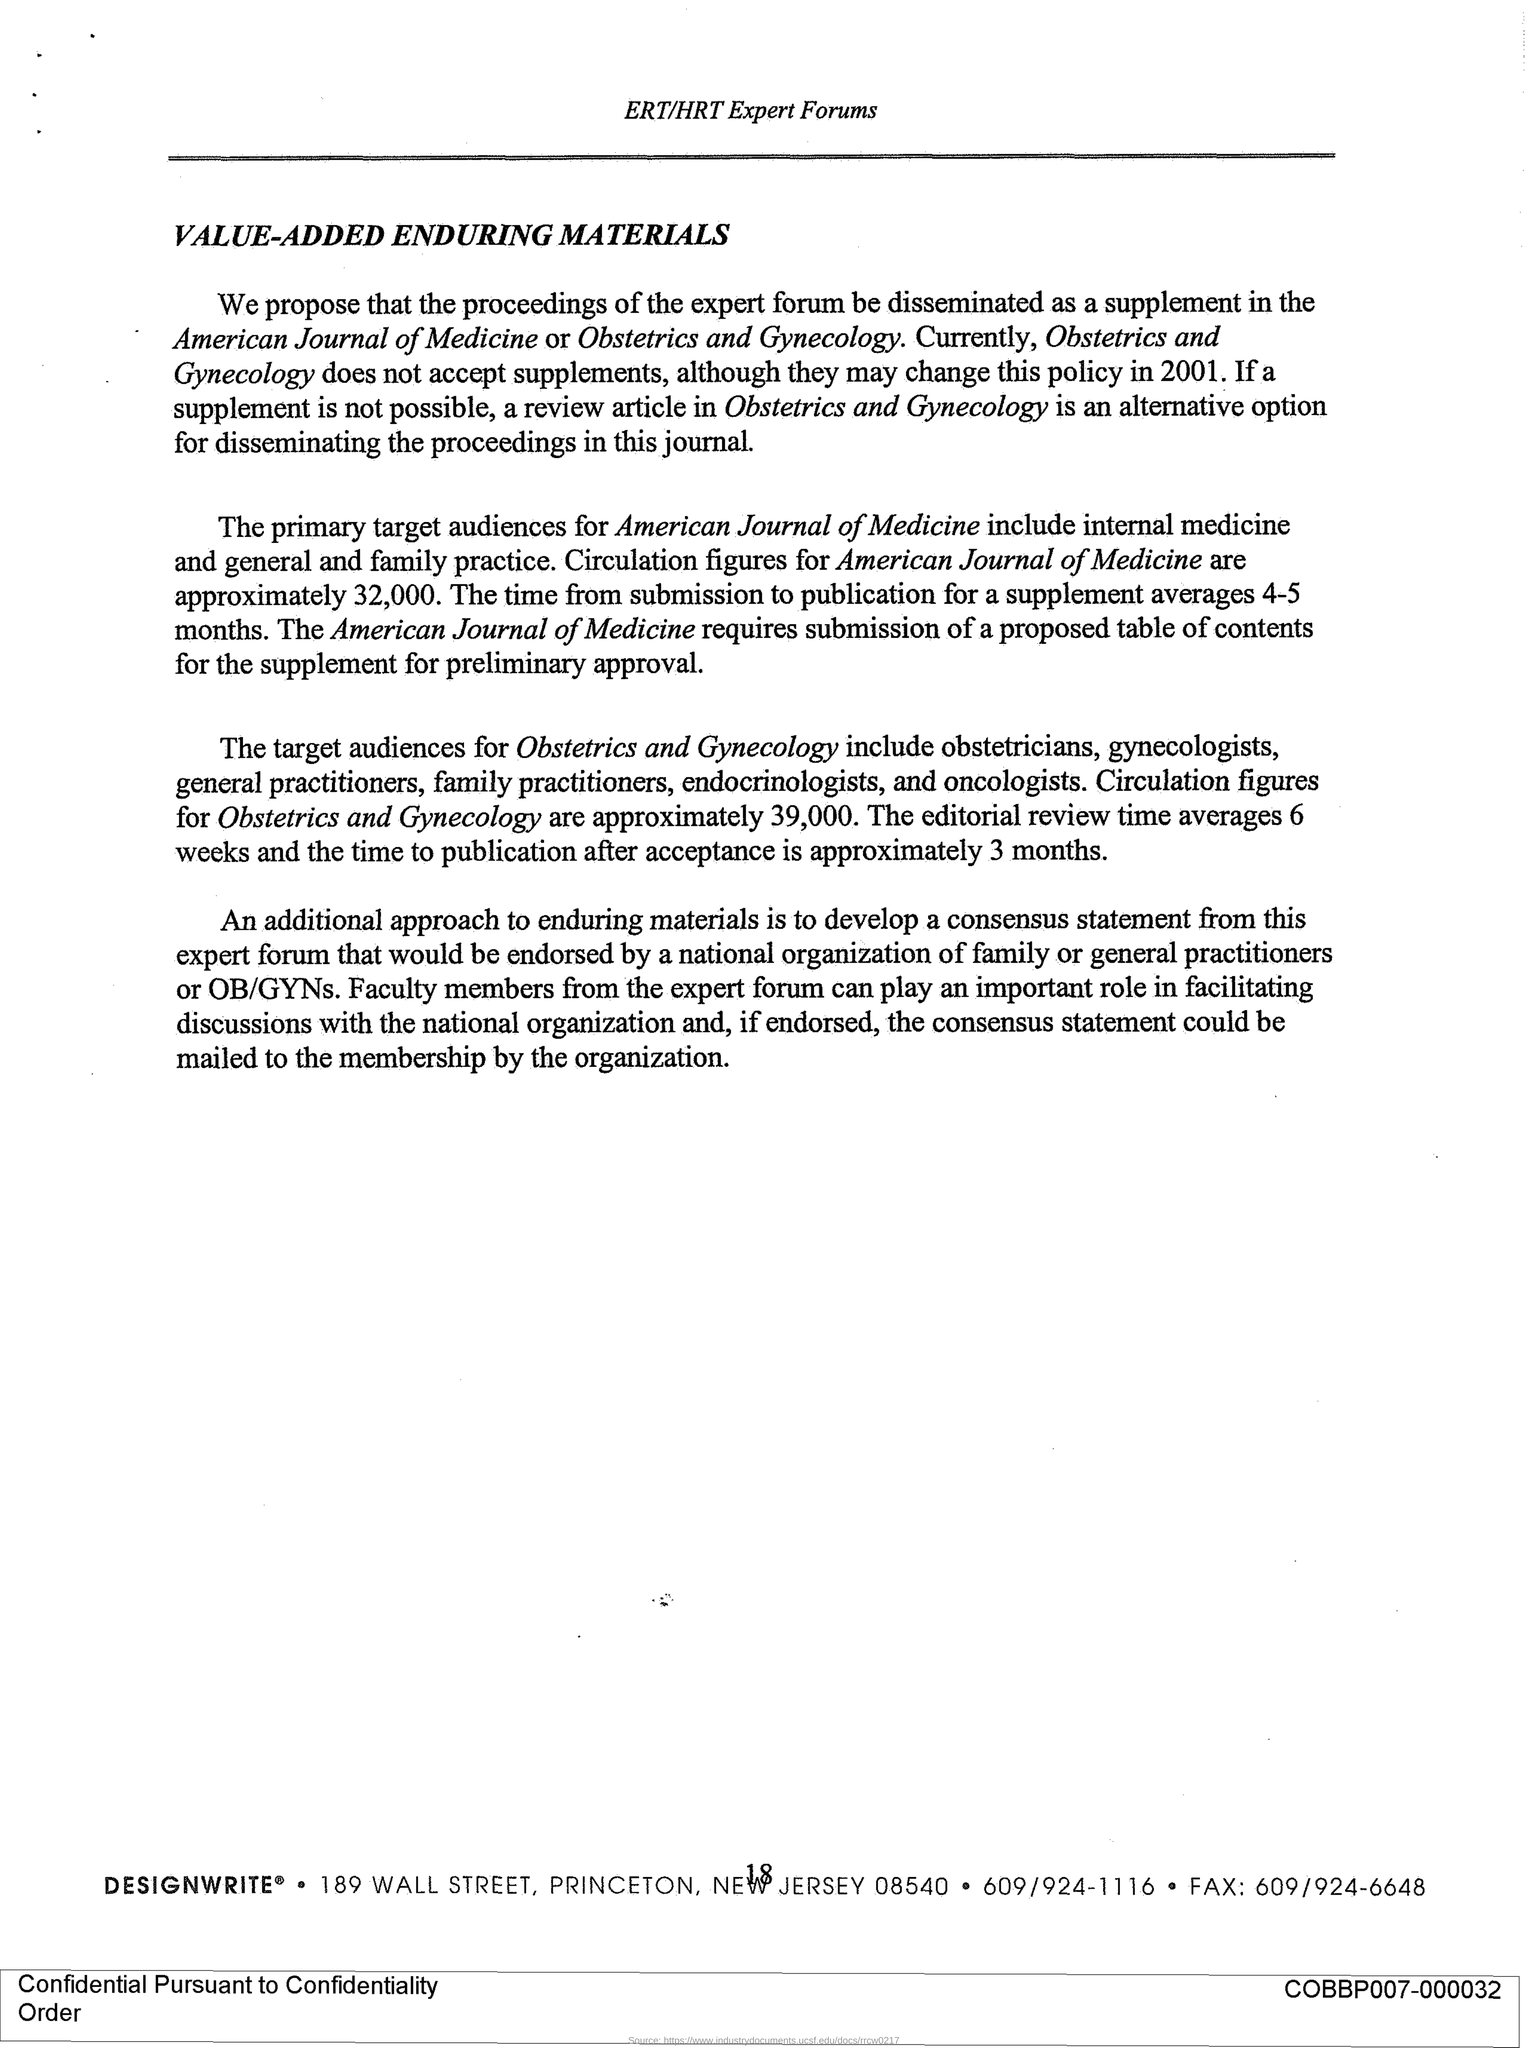What are the circulation figures for the American Journal of Medicine?
Offer a terse response. Approximately 32,000. What is the average time from submission to publication for a supplement?
Keep it short and to the point. 4-5 months. Which forum is mentioned in the header of the document?
Ensure brevity in your answer.  ERT/HRT Expert Forums. What is the title of this document?
Ensure brevity in your answer.  VALUE-ADDED ENDURING MATERIALS. 